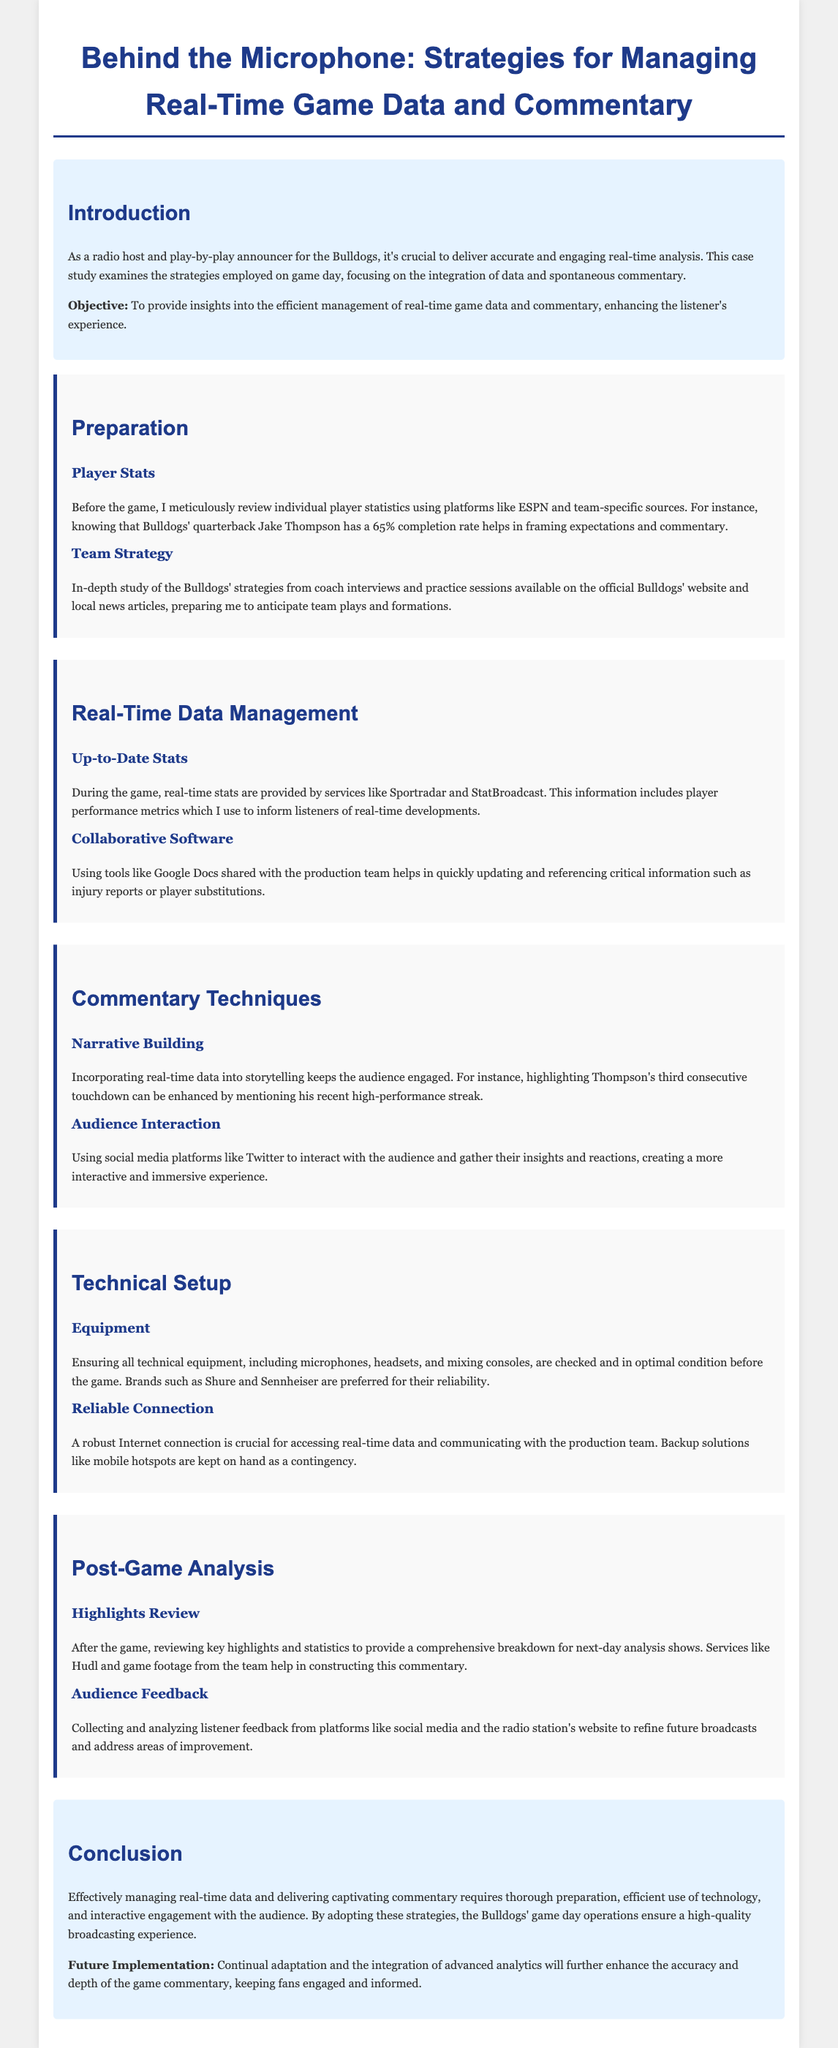What is the title of the case study? The title is found at the beginning of the document.
Answer: Behind the Microphone: Strategies for Managing Real-Time Game Data and Commentary Who is the quarterback mentioned in the case study? The quarterback is referenced in the player stats section of the document.
Answer: Jake Thompson What platform is used for real-time stats during the game? The platform is mentioned in the Real-Time Data Management section.
Answer: Sportradar Which equipment brand is preferred for reliability? This information is found in the Technical Setup section regarding equipment.
Answer: Shure What is the objective of the case study? The objective is stated in the introduction section of the document.
Answer: To provide insights into the efficient management of real-time game data and commentary What type of software is used for collaborative updates? The software is mentioned in the Real-Time Data Management section.
Answer: Google Docs How does the announcer interact with the audience? The method is described in the Commentary Techniques section of the document.
Answer: Social media platforms like Twitter What service is used for reviewing key highlights after the game? The service is noted in the Post-Game Analysis section for highlights review.
Answer: Hudl What is emphasized for ensuring a robust connection? The emphasis is found in the Technical Setup section regarding connection reliability.
Answer: Backup solutions like mobile hotspots 